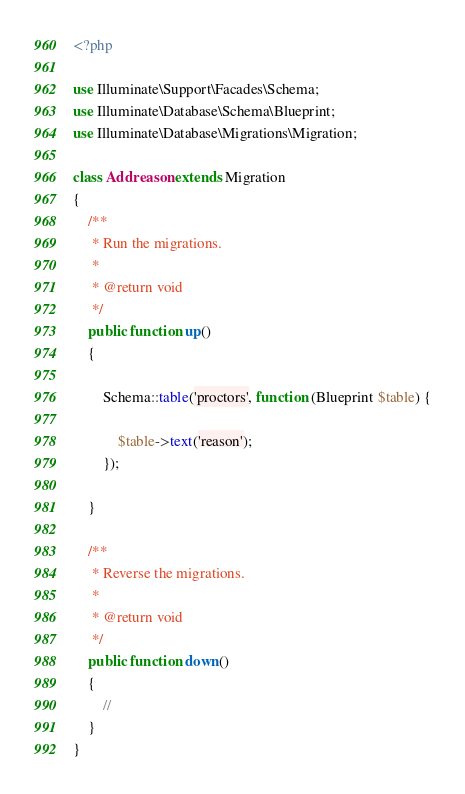Convert code to text. <code><loc_0><loc_0><loc_500><loc_500><_PHP_><?php

use Illuminate\Support\Facades\Schema;
use Illuminate\Database\Schema\Blueprint;
use Illuminate\Database\Migrations\Migration;

class Addreason extends Migration
{
    /**
     * Run the migrations.
     *
     * @return void
     */
    public function up()
    {

        Schema::table('proctors', function (Blueprint $table) {

            $table->text('reason');
        });

    }

    /**
     * Reverse the migrations.
     *
     * @return void
     */
    public function down()
    {
        //
    }
}
</code> 